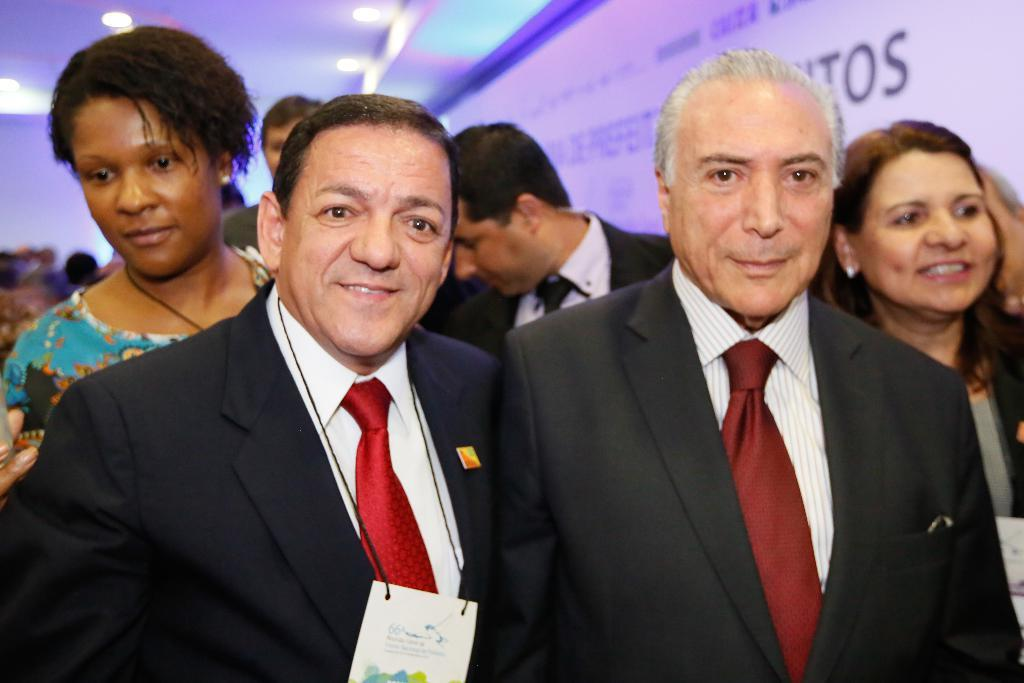What is the main subject of the image? The main subject of the image is a group of people. What is located behind the people in the image? There is a banner with text behind the people. What architectural feature is visible at the top of the image? There is a roof visible at the top of the image. What can be seen on the roof in the image? There are lights on the roof. What color crayon is being used to draw on the cave in the image? There is no cave or crayon present in the image. What channel is the group of people watching on the television in the image? There is no television present in the image. 